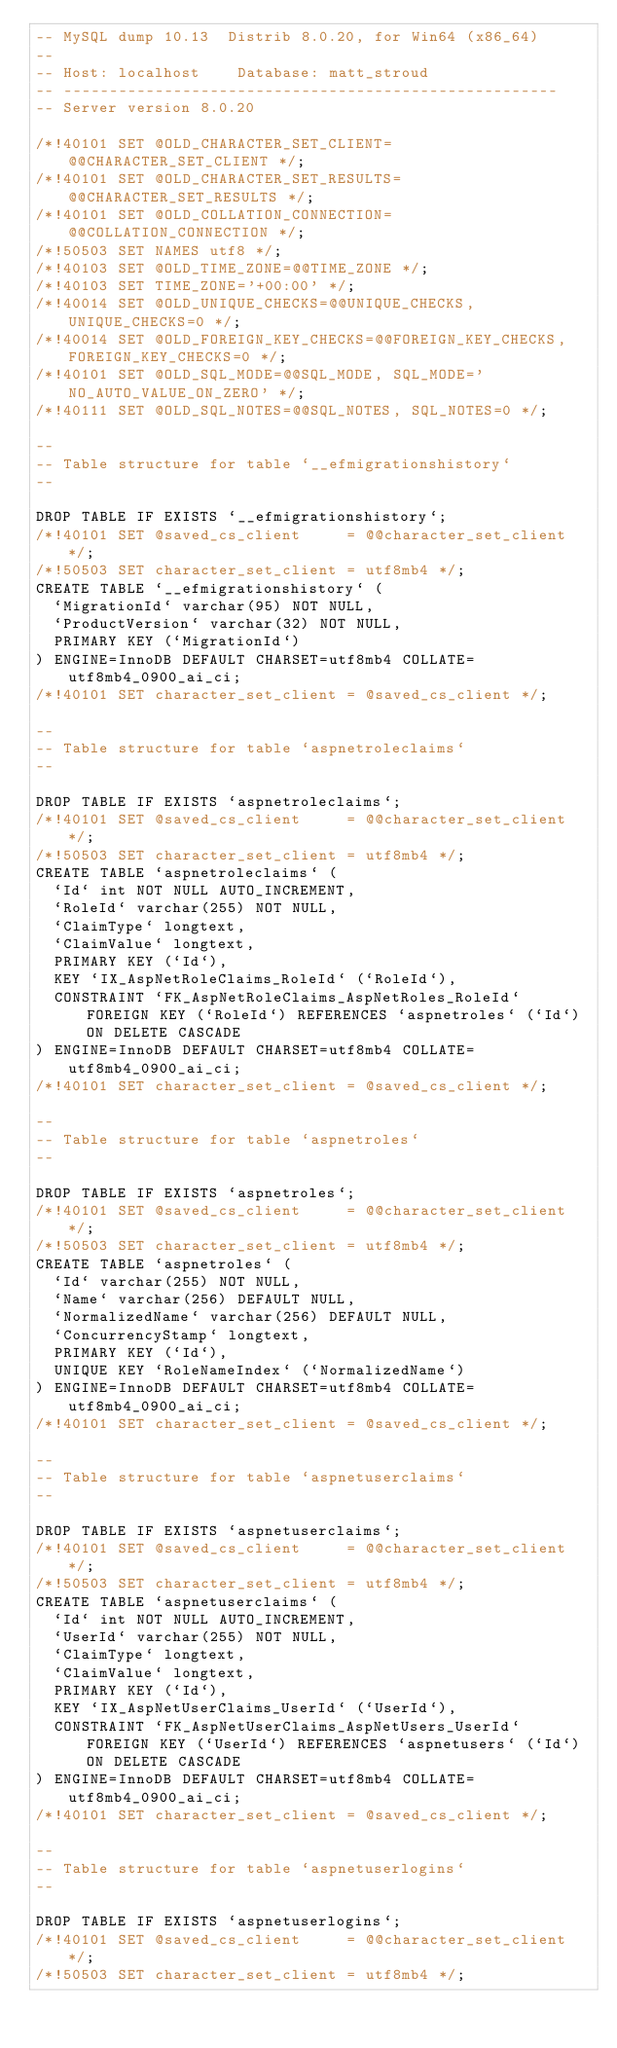<code> <loc_0><loc_0><loc_500><loc_500><_SQL_>-- MySQL dump 10.13  Distrib 8.0.20, for Win64 (x86_64)
--
-- Host: localhost    Database: matt_stroud
-- ------------------------------------------------------
-- Server version	8.0.20

/*!40101 SET @OLD_CHARACTER_SET_CLIENT=@@CHARACTER_SET_CLIENT */;
/*!40101 SET @OLD_CHARACTER_SET_RESULTS=@@CHARACTER_SET_RESULTS */;
/*!40101 SET @OLD_COLLATION_CONNECTION=@@COLLATION_CONNECTION */;
/*!50503 SET NAMES utf8 */;
/*!40103 SET @OLD_TIME_ZONE=@@TIME_ZONE */;
/*!40103 SET TIME_ZONE='+00:00' */;
/*!40014 SET @OLD_UNIQUE_CHECKS=@@UNIQUE_CHECKS, UNIQUE_CHECKS=0 */;
/*!40014 SET @OLD_FOREIGN_KEY_CHECKS=@@FOREIGN_KEY_CHECKS, FOREIGN_KEY_CHECKS=0 */;
/*!40101 SET @OLD_SQL_MODE=@@SQL_MODE, SQL_MODE='NO_AUTO_VALUE_ON_ZERO' */;
/*!40111 SET @OLD_SQL_NOTES=@@SQL_NOTES, SQL_NOTES=0 */;

--
-- Table structure for table `__efmigrationshistory`
--

DROP TABLE IF EXISTS `__efmigrationshistory`;
/*!40101 SET @saved_cs_client     = @@character_set_client */;
/*!50503 SET character_set_client = utf8mb4 */;
CREATE TABLE `__efmigrationshistory` (
  `MigrationId` varchar(95) NOT NULL,
  `ProductVersion` varchar(32) NOT NULL,
  PRIMARY KEY (`MigrationId`)
) ENGINE=InnoDB DEFAULT CHARSET=utf8mb4 COLLATE=utf8mb4_0900_ai_ci;
/*!40101 SET character_set_client = @saved_cs_client */;

--
-- Table structure for table `aspnetroleclaims`
--

DROP TABLE IF EXISTS `aspnetroleclaims`;
/*!40101 SET @saved_cs_client     = @@character_set_client */;
/*!50503 SET character_set_client = utf8mb4 */;
CREATE TABLE `aspnetroleclaims` (
  `Id` int NOT NULL AUTO_INCREMENT,
  `RoleId` varchar(255) NOT NULL,
  `ClaimType` longtext,
  `ClaimValue` longtext,
  PRIMARY KEY (`Id`),
  KEY `IX_AspNetRoleClaims_RoleId` (`RoleId`),
  CONSTRAINT `FK_AspNetRoleClaims_AspNetRoles_RoleId` FOREIGN KEY (`RoleId`) REFERENCES `aspnetroles` (`Id`) ON DELETE CASCADE
) ENGINE=InnoDB DEFAULT CHARSET=utf8mb4 COLLATE=utf8mb4_0900_ai_ci;
/*!40101 SET character_set_client = @saved_cs_client */;

--
-- Table structure for table `aspnetroles`
--

DROP TABLE IF EXISTS `aspnetroles`;
/*!40101 SET @saved_cs_client     = @@character_set_client */;
/*!50503 SET character_set_client = utf8mb4 */;
CREATE TABLE `aspnetroles` (
  `Id` varchar(255) NOT NULL,
  `Name` varchar(256) DEFAULT NULL,
  `NormalizedName` varchar(256) DEFAULT NULL,
  `ConcurrencyStamp` longtext,
  PRIMARY KEY (`Id`),
  UNIQUE KEY `RoleNameIndex` (`NormalizedName`)
) ENGINE=InnoDB DEFAULT CHARSET=utf8mb4 COLLATE=utf8mb4_0900_ai_ci;
/*!40101 SET character_set_client = @saved_cs_client */;

--
-- Table structure for table `aspnetuserclaims`
--

DROP TABLE IF EXISTS `aspnetuserclaims`;
/*!40101 SET @saved_cs_client     = @@character_set_client */;
/*!50503 SET character_set_client = utf8mb4 */;
CREATE TABLE `aspnetuserclaims` (
  `Id` int NOT NULL AUTO_INCREMENT,
  `UserId` varchar(255) NOT NULL,
  `ClaimType` longtext,
  `ClaimValue` longtext,
  PRIMARY KEY (`Id`),
  KEY `IX_AspNetUserClaims_UserId` (`UserId`),
  CONSTRAINT `FK_AspNetUserClaims_AspNetUsers_UserId` FOREIGN KEY (`UserId`) REFERENCES `aspnetusers` (`Id`) ON DELETE CASCADE
) ENGINE=InnoDB DEFAULT CHARSET=utf8mb4 COLLATE=utf8mb4_0900_ai_ci;
/*!40101 SET character_set_client = @saved_cs_client */;

--
-- Table structure for table `aspnetuserlogins`
--

DROP TABLE IF EXISTS `aspnetuserlogins`;
/*!40101 SET @saved_cs_client     = @@character_set_client */;
/*!50503 SET character_set_client = utf8mb4 */;</code> 